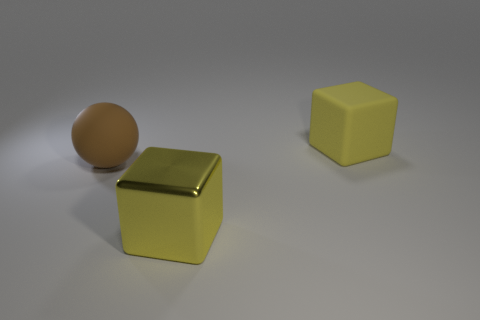Add 2 matte spheres. How many objects exist? 5 Subtract all balls. How many objects are left? 2 Add 1 big yellow blocks. How many big yellow blocks are left? 3 Add 1 metal objects. How many metal objects exist? 2 Subtract 0 blue cubes. How many objects are left? 3 Subtract all cubes. Subtract all small cyan metallic cylinders. How many objects are left? 1 